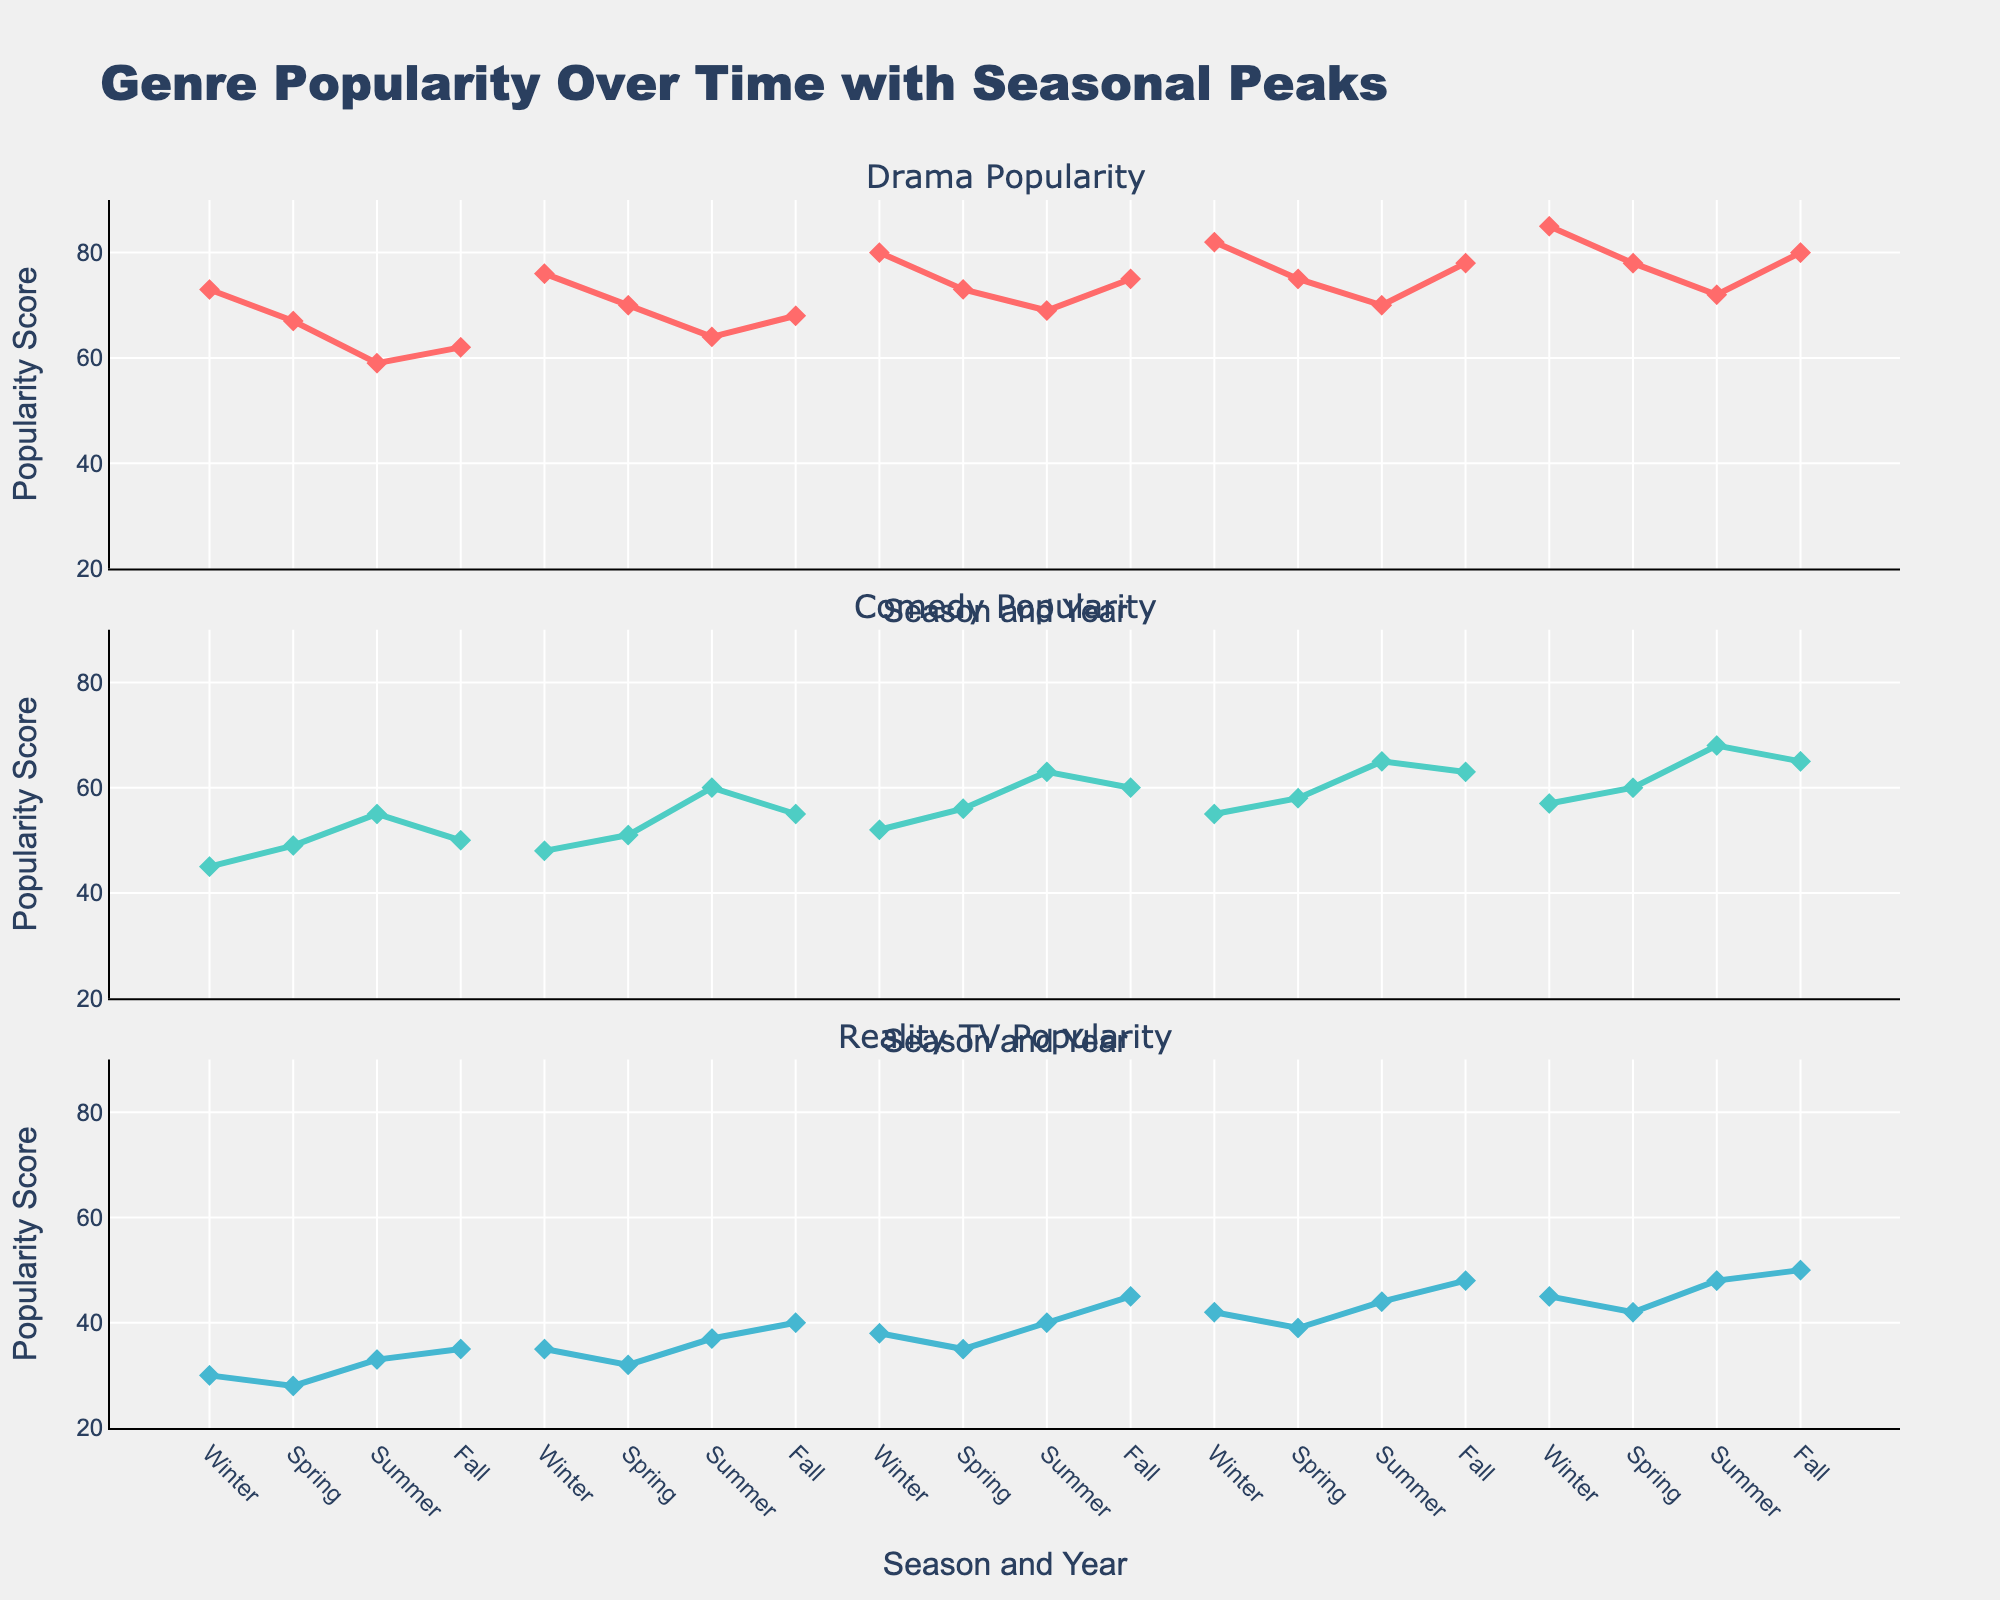What's the overall trend for the Drama genre from 2018 to 2022? The trend for the Drama genre can be identified by observing the line plots for each year from 2018 to 2022. By comparing the endpoints of each year's winter season, it is clear that the popularity score increases each year. For instance, starting from 73 in 2018 and ending at 85 in 2022.
Answer: The popularity of the Drama genre consistently increases from 2018 to 2022 Which season consistently has the highest popularity for the Drama genre? To determine the season with the highest popularity for the Drama genre, we need to observe each season's scores across all years. Winter consistently has the highest scores: 73 (2018), 76 (2019), 80 (2020), 82 (2021), and 85 (2022).
Answer: Winter Compare the popularity trends of Comedy and Reality TV genres in the summer of each year. By examining the three plots, Comedy's summer popularity scores climb from 55 (2018) to 68 (2022). Reality TV, however, rises more modestly from 33 (2018) to 48 (2022). Comedy consistently shows a higher summer popularity than Reality TV each year.
Answer: Comedy shows a higher and increasing trend compared to Reality TV in the summer What's the difference in popularity between Drama and Comedy in Fall 2020? Observing the Fall points for Drama and Comedy in 2020, the scores are 75 and 60, respectively. The difference is calculated by subtracting the Comedy score from the Drama score: 75 - 60 = 15.
Answer: 15 How does the popularity of Reality TV in Winter 2022 compare to Winter 2018? The Winter popularity score for Reality TV in 2018 is 30, while in 2022, it is 45. The change is calculated by subtracting the 2018 score from the 2022 score: 45 - 30 = 15.
Answer: Reality TV's winter popularity increased by 15 points from 2018 to 2022 Which genre had the most significant change in popularity in Fall from 2018 to 2022? To identify the genre with the biggest change, we compare the Fall scores for each genre between 2018 and 2022. Drama changes from 62 to 80, Comedy from 50 to 65, and Reality TV from 35 to 50. The changes are 18, 15, and 15 points respectively; thus, Drama has the most significant change.
Answer: Drama Does the popularity of any genre exhibit a cyclic pattern? Examining the stair plot, cyclic patterns can be identified if there is a seasonality component, meaning scores rise and fall in a similar manner each year. For instance, all genres show higher scores in Winter and lower scores in Summer, indicating some cyclic behavior.
Answer: Yes, all genres show some cyclic pattern, especially higher popularity in Winter and lower in Summer 